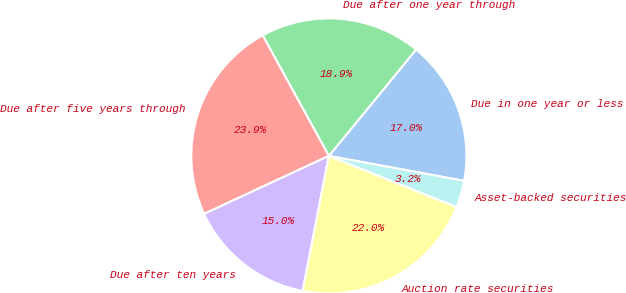Convert chart. <chart><loc_0><loc_0><loc_500><loc_500><pie_chart><fcel>Due in one year or less<fcel>Due after one year through<fcel>Due after five years through<fcel>Due after ten years<fcel>Auction rate securities<fcel>Asset-backed securities<nl><fcel>16.97%<fcel>18.92%<fcel>23.93%<fcel>15.03%<fcel>21.99%<fcel>3.16%<nl></chart> 